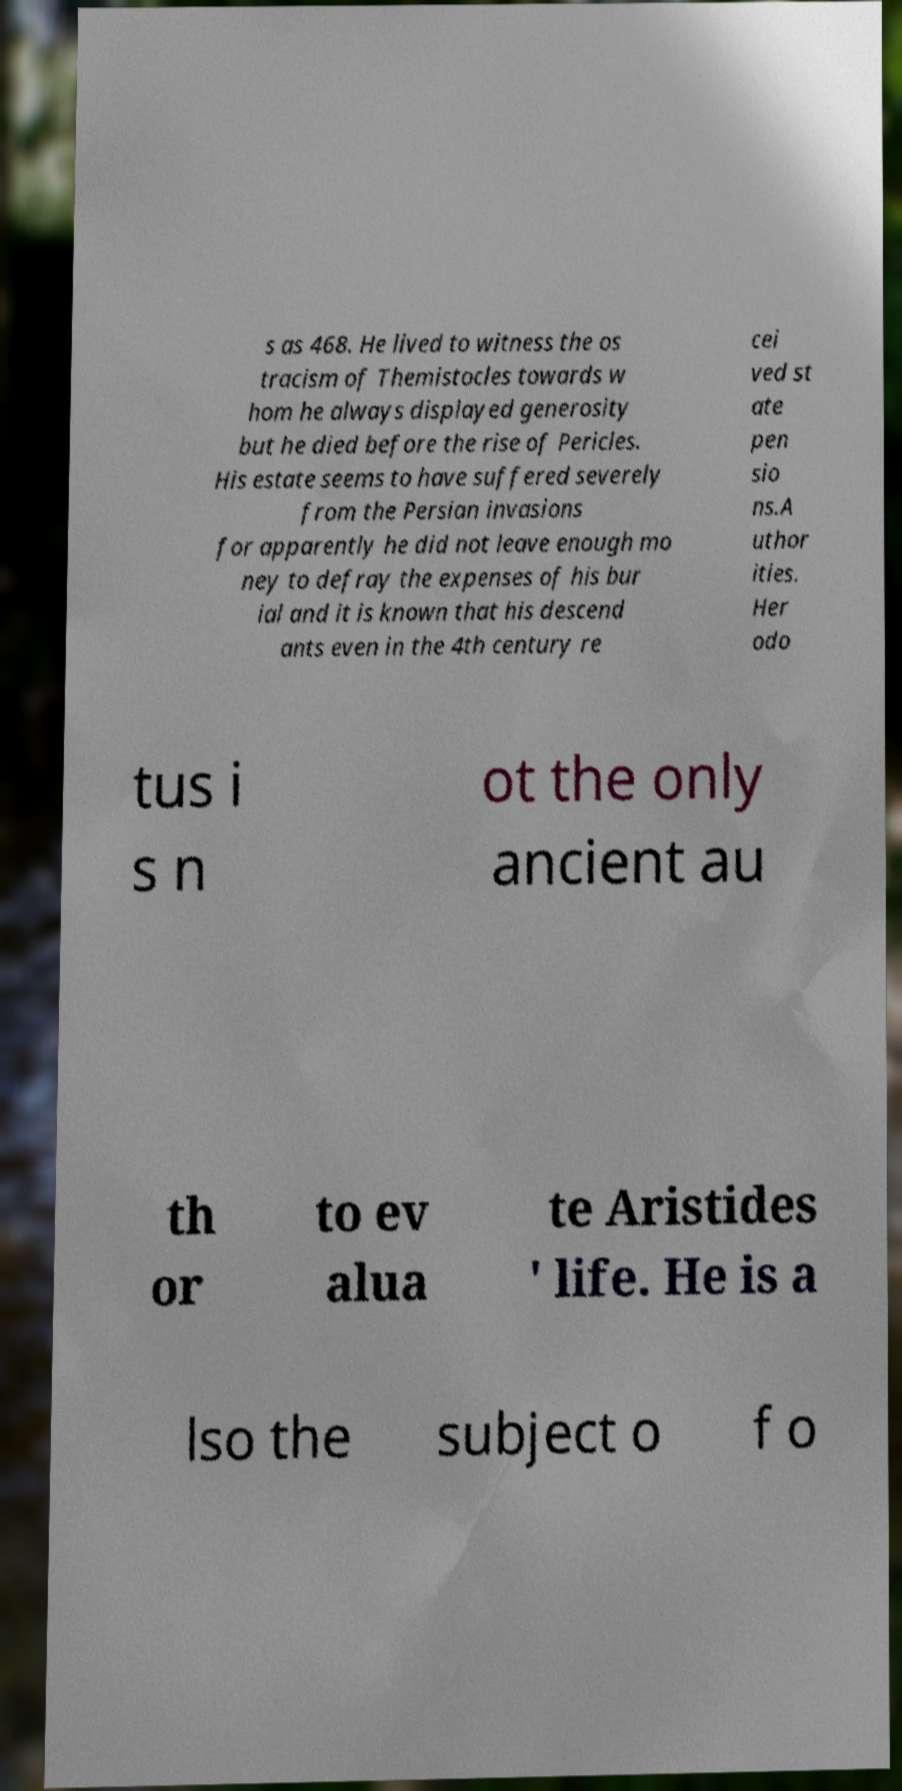Could you extract and type out the text from this image? s as 468. He lived to witness the os tracism of Themistocles towards w hom he always displayed generosity but he died before the rise of Pericles. His estate seems to have suffered severely from the Persian invasions for apparently he did not leave enough mo ney to defray the expenses of his bur ial and it is known that his descend ants even in the 4th century re cei ved st ate pen sio ns.A uthor ities. Her odo tus i s n ot the only ancient au th or to ev alua te Aristides ' life. He is a lso the subject o f o 